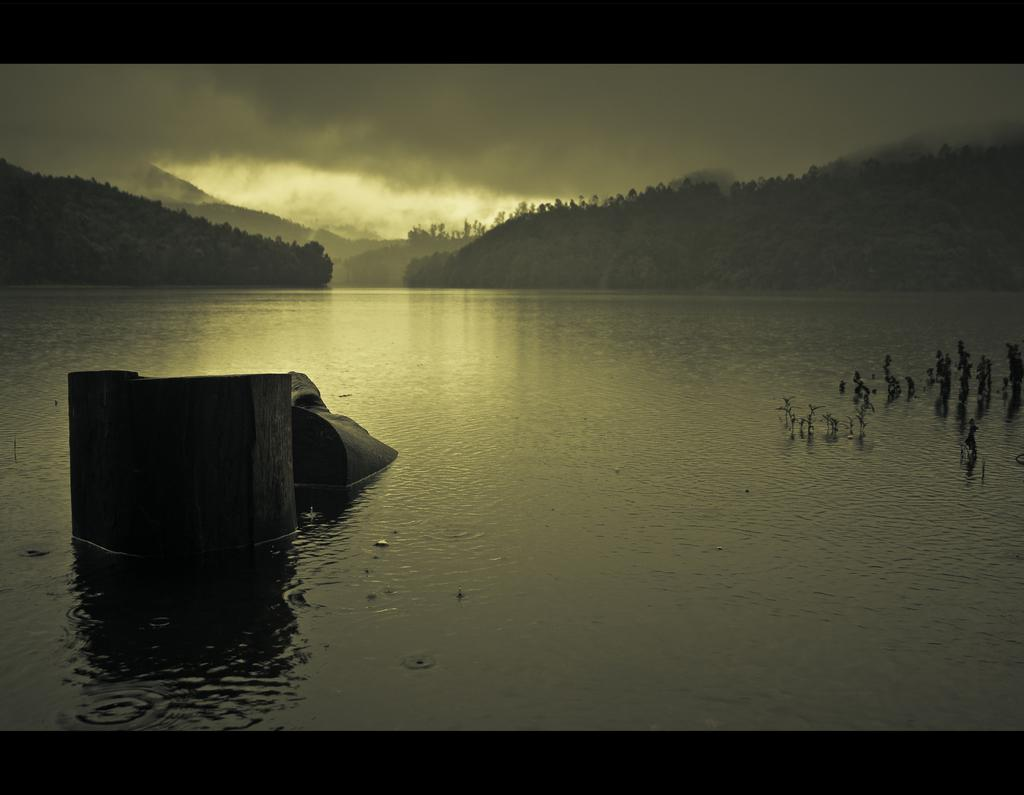What type of natural features can be seen in the image? There are trees, mountains, and water visible in the image. Can you describe the water in the image? The water appears to have a wall-like structure. What is visible in the background of the image? The sky is visible in the background of the image. What can be seen in the sky? Clouds are present in the sky. How many times does the water fall from the wall-like structure in the image? There is no indication of the water falling from the wall-like structure in the image. What type of ocean can be seen in the image? There is no ocean present in the image; it features water with a wall-like structure. 